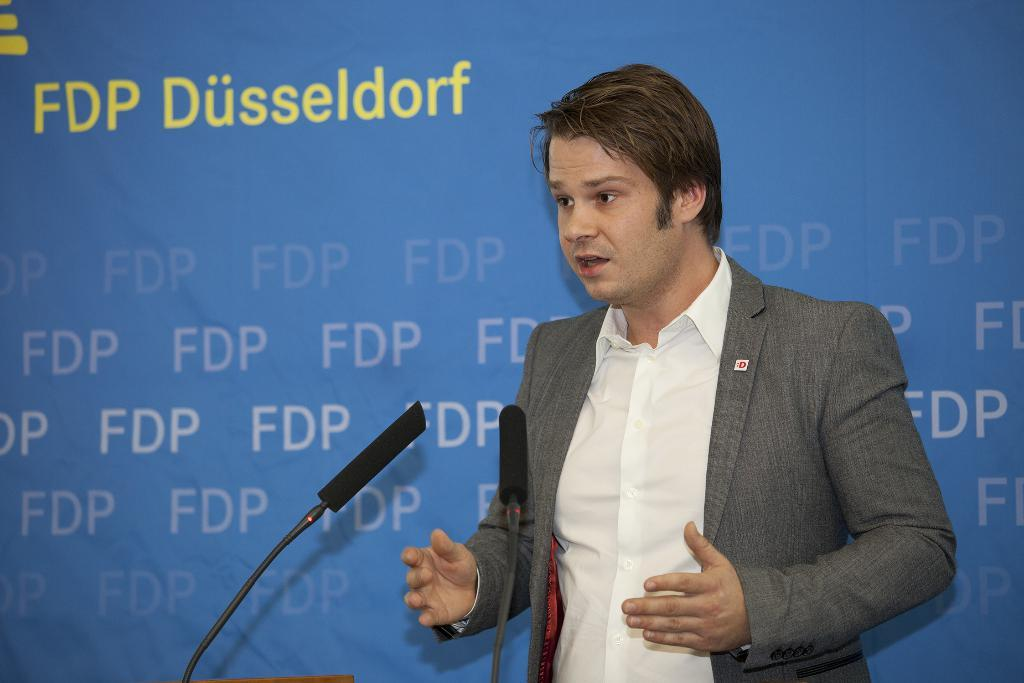Who is present in the image? There is a person in the image. What is the person wearing? The person is wearing a grey suit and a white shirt. What is the person's posture in the image? The person is standing. What can be seen in the background of the image? There is a blue sheet in the background of the image. What books does the person have on their birthday in the image? There is no mention of a birthday or books in the image; it only shows a person wearing a grey suit and a white shirt, standing with a blue sheet in the background. 